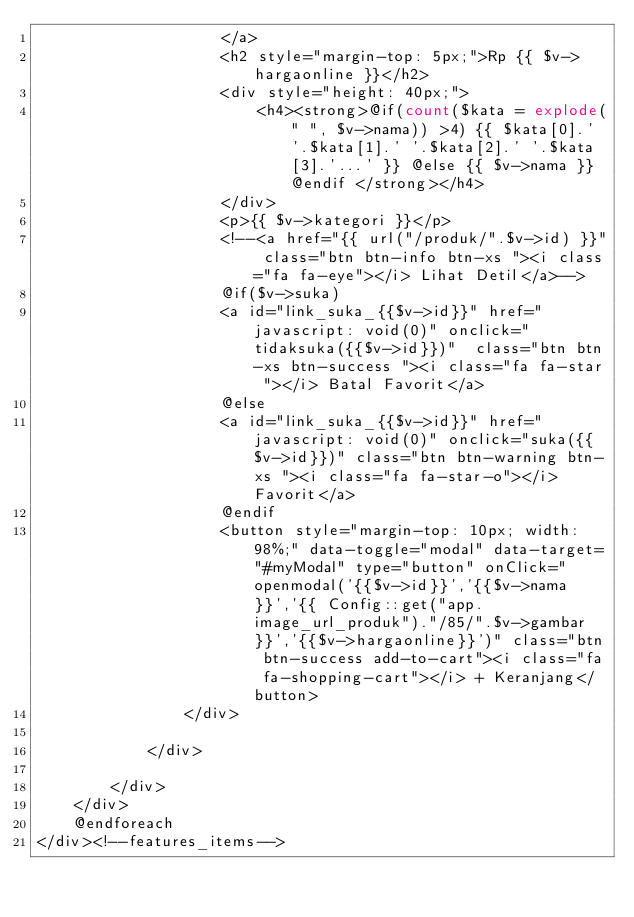Convert code to text. <code><loc_0><loc_0><loc_500><loc_500><_PHP_>                    </a>
                    <h2 style="margin-top: 5px;">Rp {{ $v->hargaonline }}</h2>
                    <div style="height: 40px;">
                        <h4><strong>@if(count($kata = explode(" ", $v->nama)) >4) {{ $kata[0].' '.$kata[1].' '.$kata[2].' '.$kata[3].'...' }} @else {{ $v->nama }} @endif </strong></h4>
                    </div>
                    <p>{{ $v->kategori }}</p>
                    <!--<a href="{{ url("/produk/".$v->id) }}" class="btn btn-info btn-xs "><i class="fa fa-eye"></i> Lihat Detil</a>-->
                    @if($v->suka)
                    <a id="link_suka_{{$v->id}}" href="javascript: void(0)" onclick="tidaksuka({{$v->id}})"  class="btn btn-xs btn-success "><i class="fa fa-star "></i> Batal Favorit</a>
                    @else
                    <a id="link_suka_{{$v->id}}" href="javascript: void(0)" onclick="suka({{$v->id}})" class="btn btn-warning btn-xs "><i class="fa fa-star-o"></i> Favorit</a>
                    @endif
                    <button style="margin-top: 10px; width: 98%;" data-toggle="modal" data-target="#myModal" type="button" onClick="openmodal('{{$v->id}}','{{$v->nama}}','{{ Config::get("app.image_url_produk")."/85/".$v->gambar }}','{{$v->hargaonline}}')" class="btn btn-success add-to-cart"><i class="fa fa-shopping-cart"></i> + Keranjang</button>
                </div>

            </div>

        </div>
    </div>    
    @endforeach
</div><!--features_items--></code> 